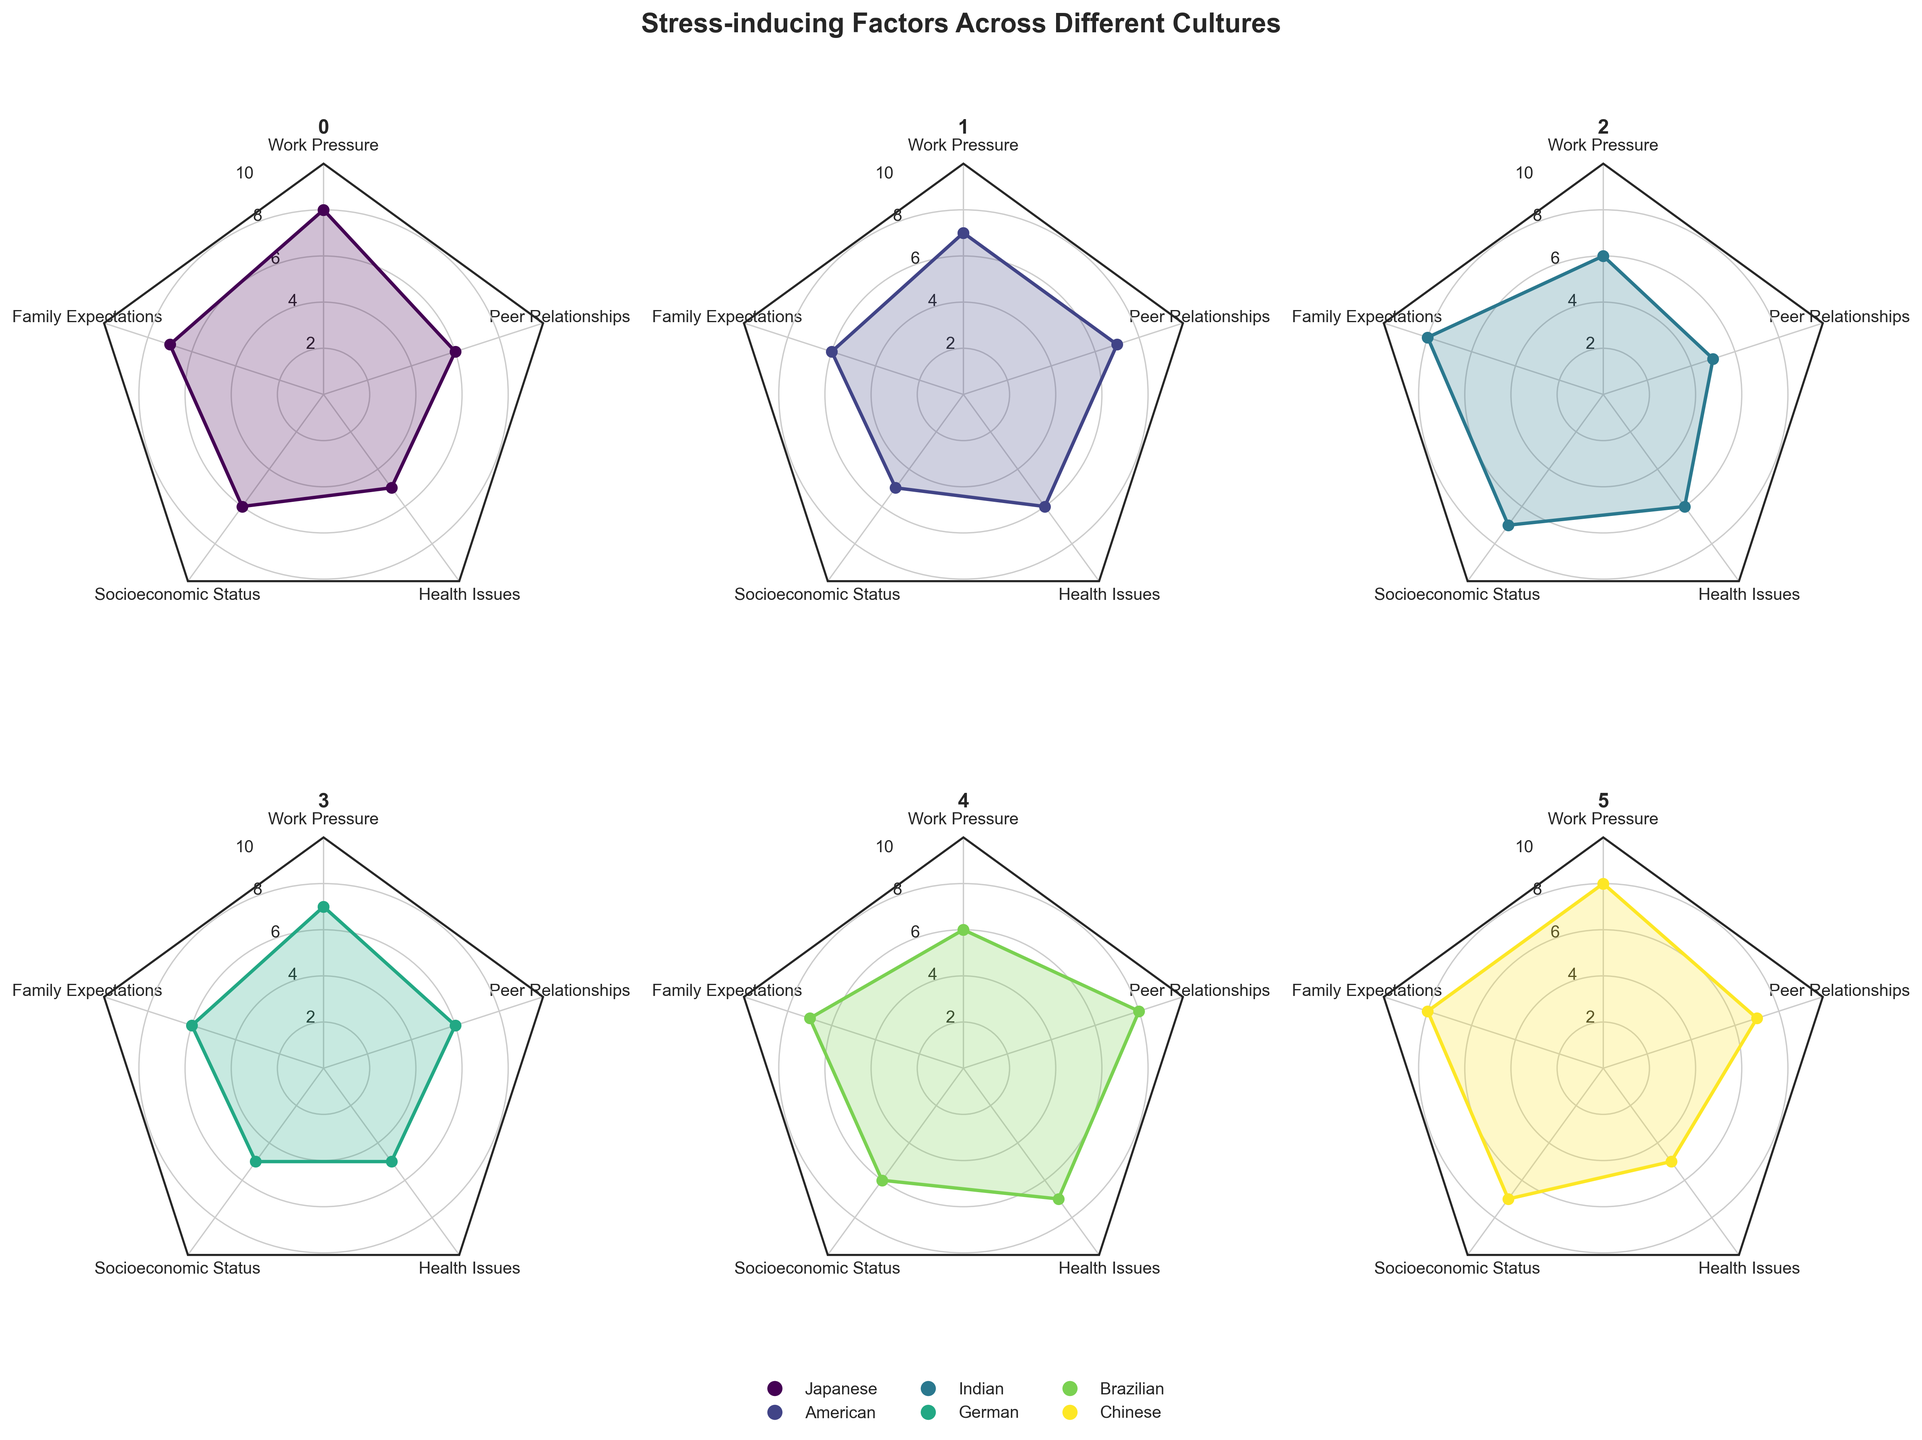What is the title of the figure? The title is usually displayed at the top of the figure, making it easily identifiable.
Answer: Stress-inducing Factors Across Different Cultures Which culture has the highest work pressure? Look for the culture with the highest value on the work pressure axis. Japanese and Chinese cultures both have the highest value of 8.
Answer: Japanese, Chinese How many cultures have family expectations as the highest stress-inducing factor? Check each culture's values and see how many have the highest stress-inducing factor value at family expectations. Indian, Chinese both have family expectations at 8, which is their highest factor.
Answer: 2 Which culture has the lowest value in health issues? Identify the values under health issues for each culture and determine the lowest one. German and Japanese both have the lowest value of 5.
Answer: German, Japanese What is the median value of socioeconomic status across all cultures? List the socioeconomic status values (6, 5, 7, 5, 6, 7), sort them, and find the middle value.
Answer: 6 Which culture has the most balanced stress-inducing factors, i.e., closest values across all factors? Check for the culture with values closest to each other across all five factors. American culture has values of 7, 6, 5, 6, 7, which are close to each other.
Answer: American Between Brazilian and Indian cultures, which one has a higher peer relationships stress level? Compare the peer relationships values for Brazilian (8) and Indian (5).
Answer: Brazilian How do Japanese and American cultures compare in terms of health issues? Compare their values for health issues: Japanese (5) and American (6).
Answer: American has a higher value in health issues Which cultures have socioeconomic status as one of their top two stress-inducing factors? Check each culture's values to see if socioeconomic status ranks in the top two for any of them. Indian and Chinese have socioeconomic status as their second highest.
Answer: Indian, Chinese 